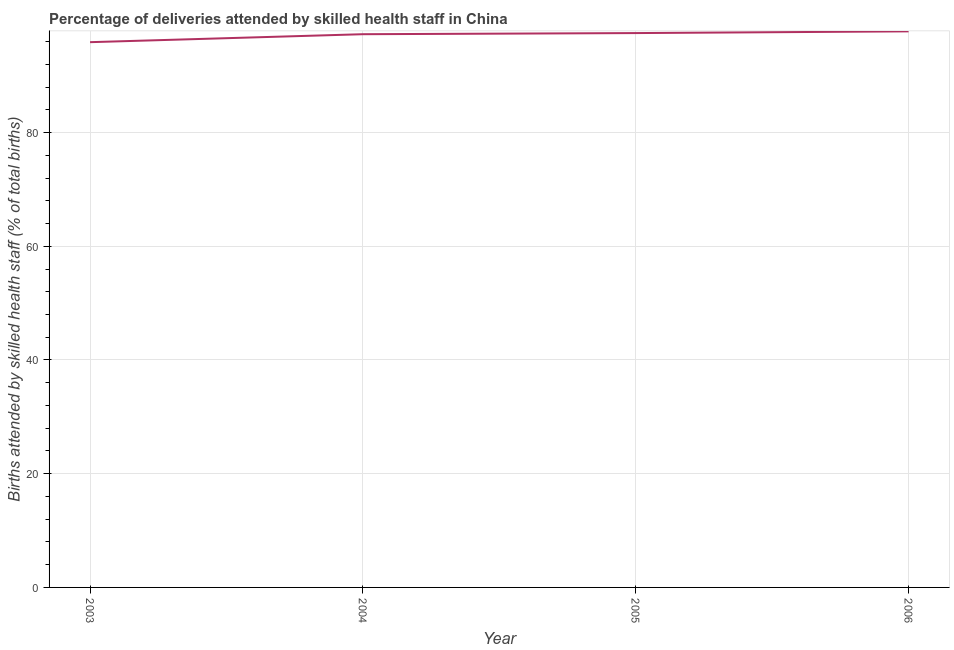What is the number of births attended by skilled health staff in 2004?
Offer a terse response. 97.3. Across all years, what is the maximum number of births attended by skilled health staff?
Provide a succinct answer. 97.8. Across all years, what is the minimum number of births attended by skilled health staff?
Keep it short and to the point. 95.9. In which year was the number of births attended by skilled health staff minimum?
Provide a short and direct response. 2003. What is the sum of the number of births attended by skilled health staff?
Your answer should be compact. 388.5. What is the difference between the number of births attended by skilled health staff in 2005 and 2006?
Provide a short and direct response. -0.3. What is the average number of births attended by skilled health staff per year?
Your response must be concise. 97.12. What is the median number of births attended by skilled health staff?
Give a very brief answer. 97.4. In how many years, is the number of births attended by skilled health staff greater than 56 %?
Provide a short and direct response. 4. What is the ratio of the number of births attended by skilled health staff in 2005 to that in 2006?
Offer a terse response. 1. Is the number of births attended by skilled health staff in 2005 less than that in 2006?
Ensure brevity in your answer.  Yes. What is the difference between the highest and the second highest number of births attended by skilled health staff?
Provide a short and direct response. 0.3. Is the sum of the number of births attended by skilled health staff in 2004 and 2006 greater than the maximum number of births attended by skilled health staff across all years?
Your answer should be very brief. Yes. What is the difference between the highest and the lowest number of births attended by skilled health staff?
Make the answer very short. 1.9. In how many years, is the number of births attended by skilled health staff greater than the average number of births attended by skilled health staff taken over all years?
Ensure brevity in your answer.  3. Does the number of births attended by skilled health staff monotonically increase over the years?
Give a very brief answer. Yes. How many lines are there?
Your answer should be very brief. 1. How many years are there in the graph?
Your answer should be very brief. 4. What is the difference between two consecutive major ticks on the Y-axis?
Keep it short and to the point. 20. Are the values on the major ticks of Y-axis written in scientific E-notation?
Offer a very short reply. No. Does the graph contain any zero values?
Ensure brevity in your answer.  No. What is the title of the graph?
Your answer should be very brief. Percentage of deliveries attended by skilled health staff in China. What is the label or title of the X-axis?
Your response must be concise. Year. What is the label or title of the Y-axis?
Give a very brief answer. Births attended by skilled health staff (% of total births). What is the Births attended by skilled health staff (% of total births) of 2003?
Offer a very short reply. 95.9. What is the Births attended by skilled health staff (% of total births) of 2004?
Make the answer very short. 97.3. What is the Births attended by skilled health staff (% of total births) in 2005?
Offer a very short reply. 97.5. What is the Births attended by skilled health staff (% of total births) of 2006?
Offer a terse response. 97.8. What is the difference between the Births attended by skilled health staff (% of total births) in 2003 and 2004?
Your answer should be very brief. -1.4. What is the difference between the Births attended by skilled health staff (% of total births) in 2004 and 2005?
Your answer should be very brief. -0.2. What is the difference between the Births attended by skilled health staff (% of total births) in 2005 and 2006?
Provide a succinct answer. -0.3. What is the ratio of the Births attended by skilled health staff (% of total births) in 2004 to that in 2006?
Make the answer very short. 0.99. What is the ratio of the Births attended by skilled health staff (% of total births) in 2005 to that in 2006?
Provide a succinct answer. 1. 